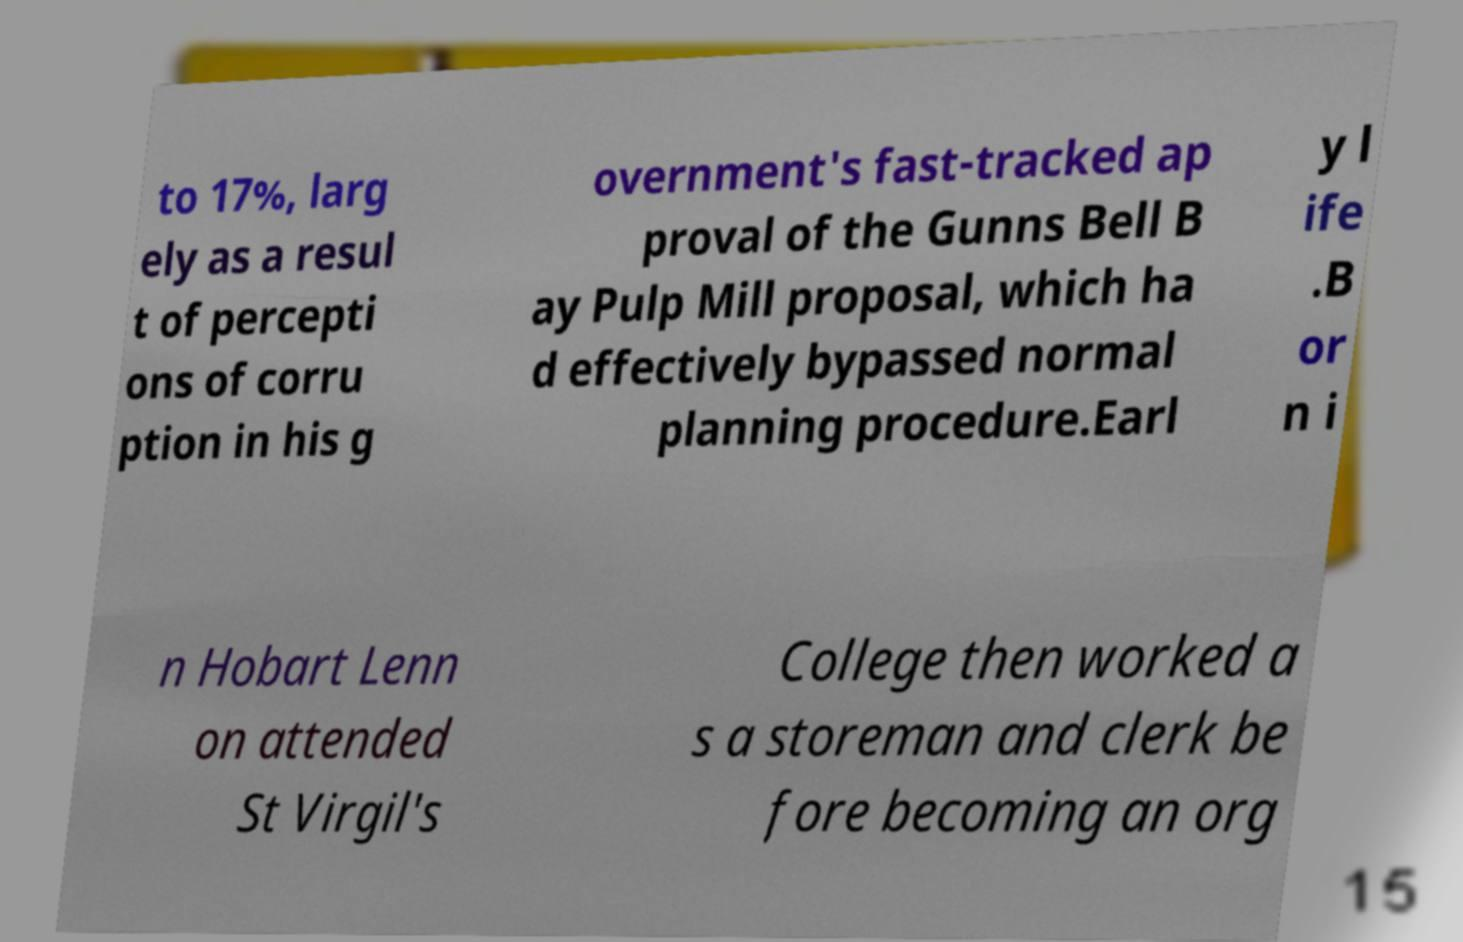Please read and relay the text visible in this image. What does it say? to 17%, larg ely as a resul t of percepti ons of corru ption in his g overnment's fast-tracked ap proval of the Gunns Bell B ay Pulp Mill proposal, which ha d effectively bypassed normal planning procedure.Earl y l ife .B or n i n Hobart Lenn on attended St Virgil's College then worked a s a storeman and clerk be fore becoming an org 